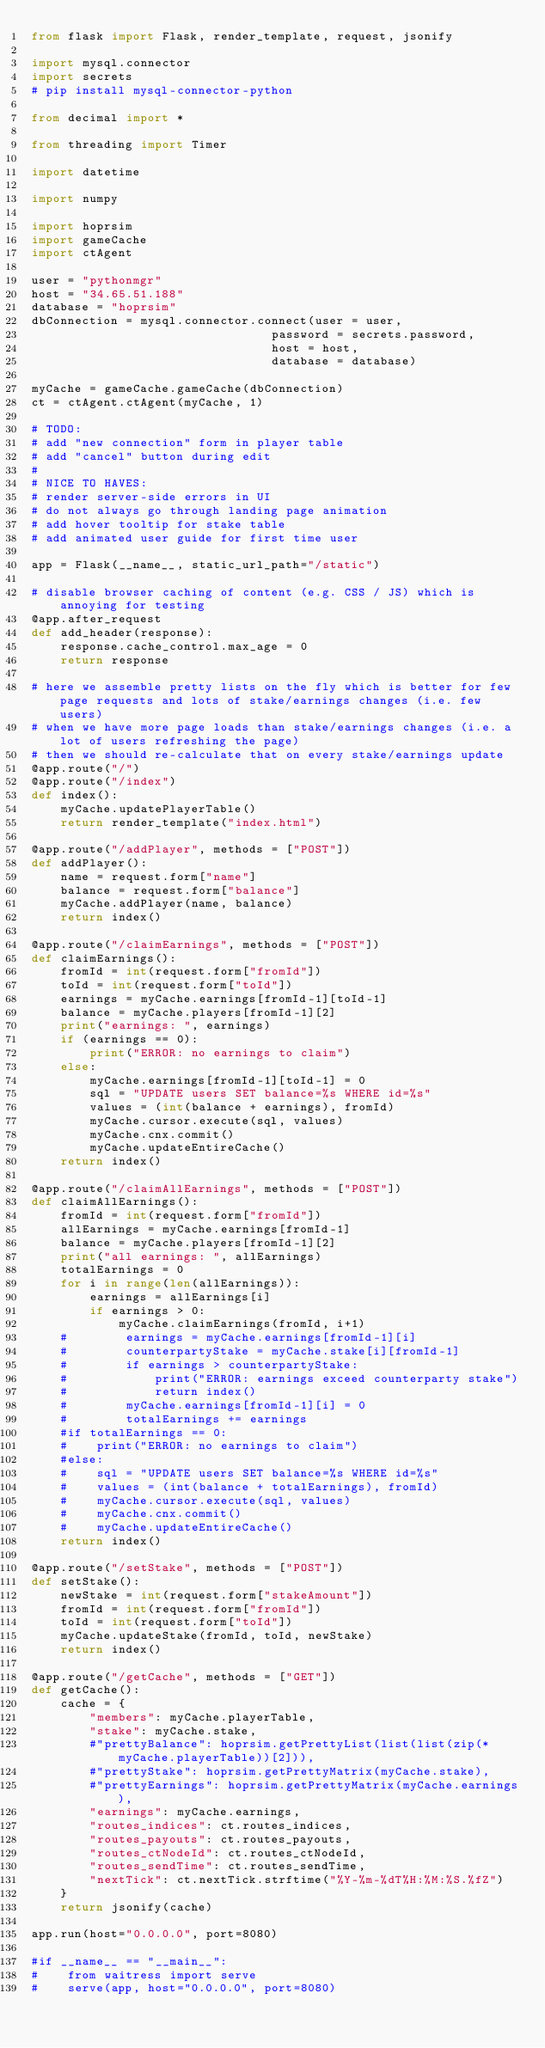Convert code to text. <code><loc_0><loc_0><loc_500><loc_500><_Python_>from flask import Flask, render_template, request, jsonify

import mysql.connector
import secrets
# pip install mysql-connector-python

from decimal import *

from threading import Timer

import datetime

import numpy

import hoprsim
import gameCache
import ctAgent

user = "pythonmgr"
host = "34.65.51.188"
database = "hoprsim"
dbConnection = mysql.connector.connect(user = user,
                                 password = secrets.password,
                                 host = host,
                                 database = database)

myCache = gameCache.gameCache(dbConnection)
ct = ctAgent.ctAgent(myCache, 1)

# TODO:
# add "new connection" form in player table
# add "cancel" button during edit
#
# NICE TO HAVES:
# render server-side errors in UI
# do not always go through landing page animation
# add hover tooltip for stake table
# add animated user guide for first time user

app = Flask(__name__, static_url_path="/static")

# disable browser caching of content (e.g. CSS / JS) which is annoying for testing 
@app.after_request
def add_header(response):
    response.cache_control.max_age = 0
    return response

# here we assemble pretty lists on the fly which is better for few page requests and lots of stake/earnings changes (i.e. few users)
# when we have more page loads than stake/earnings changes (i.e. a lot of users refreshing the page)
# then we should re-calculate that on every stake/earnings update
@app.route("/")
@app.route("/index")
def index():
    myCache.updatePlayerTable()
    return render_template("index.html")

@app.route("/addPlayer", methods = ["POST"])
def addPlayer():
    name = request.form["name"]
    balance = request.form["balance"]
    myCache.addPlayer(name, balance)
    return index()

@app.route("/claimEarnings", methods = ["POST"])
def claimEarnings():
    fromId = int(request.form["fromId"])
    toId = int(request.form["toId"])
    earnings = myCache.earnings[fromId-1][toId-1]
    balance = myCache.players[fromId-1][2]
    print("earnings: ", earnings)
    if (earnings == 0):
        print("ERROR: no earnings to claim")
    else:
        myCache.earnings[fromId-1][toId-1] = 0
        sql = "UPDATE users SET balance=%s WHERE id=%s"
        values = (int(balance + earnings), fromId)
        myCache.cursor.execute(sql, values)
        myCache.cnx.commit()
        myCache.updateEntireCache()
    return index()

@app.route("/claimAllEarnings", methods = ["POST"])
def claimAllEarnings():
    fromId = int(request.form["fromId"])
    allEarnings = myCache.earnings[fromId-1]
    balance = myCache.players[fromId-1][2]
    print("all earnings: ", allEarnings)
    totalEarnings = 0
    for i in range(len(allEarnings)):
        earnings = allEarnings[i]
        if earnings > 0:
            myCache.claimEarnings(fromId, i+1)
    #        earnings = myCache.earnings[fromId-1][i]
    #        counterpartyStake = myCache.stake[i][fromId-1]
    #        if earnings > counterpartyStake:
    #            print("ERROR: earnings exceed counterparty stake")
    #            return index()
    #        myCache.earnings[fromId-1][i] = 0
    #        totalEarnings += earnings
    #if totalEarnings == 0:
    #    print("ERROR: no earnings to claim")
    #else:
    #    sql = "UPDATE users SET balance=%s WHERE id=%s"
    #    values = (int(balance + totalEarnings), fromId)
    #    myCache.cursor.execute(sql, values)
    #    myCache.cnx.commit()
    #    myCache.updateEntireCache()
    return index()

@app.route("/setStake", methods = ["POST"])
def setStake():
    newStake = int(request.form["stakeAmount"])
    fromId = int(request.form["fromId"])
    toId = int(request.form["toId"])
    myCache.updateStake(fromId, toId, newStake)
    return index()

@app.route("/getCache", methods = ["GET"])
def getCache():
    cache = {
        "members": myCache.playerTable,
        "stake": myCache.stake,
        #"prettyBalance": hoprsim.getPrettyList(list(list(zip(*myCache.playerTable))[2])),
        #"prettyStake": hoprsim.getPrettyMatrix(myCache.stake),
        #"prettyEarnings": hoprsim.getPrettyMatrix(myCache.earnings),
        "earnings": myCache.earnings,
        "routes_indices": ct.routes_indices,
        "routes_payouts": ct.routes_payouts,
        "routes_ctNodeId": ct.routes_ctNodeId,
        "routes_sendTime": ct.routes_sendTime,
        "nextTick": ct.nextTick.strftime("%Y-%m-%dT%H:%M:%S.%fZ")
    }
    return jsonify(cache)

app.run(host="0.0.0.0", port=8080)

#if __name__ == "__main__":
#    from waitress import serve
#    serve(app, host="0.0.0.0", port=8080)

</code> 